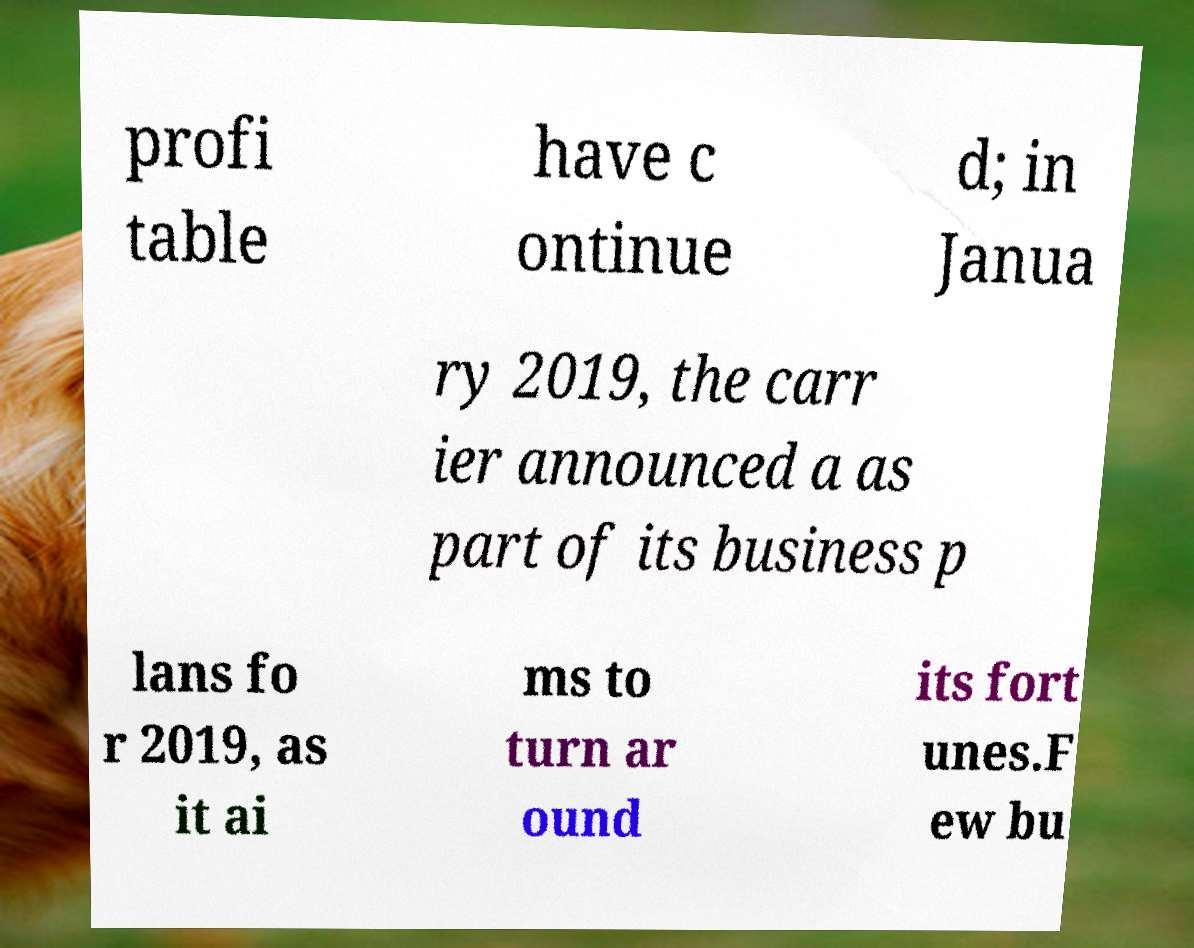Could you extract and type out the text from this image? profi table have c ontinue d; in Janua ry 2019, the carr ier announced a as part of its business p lans fo r 2019, as it ai ms to turn ar ound its fort unes.F ew bu 